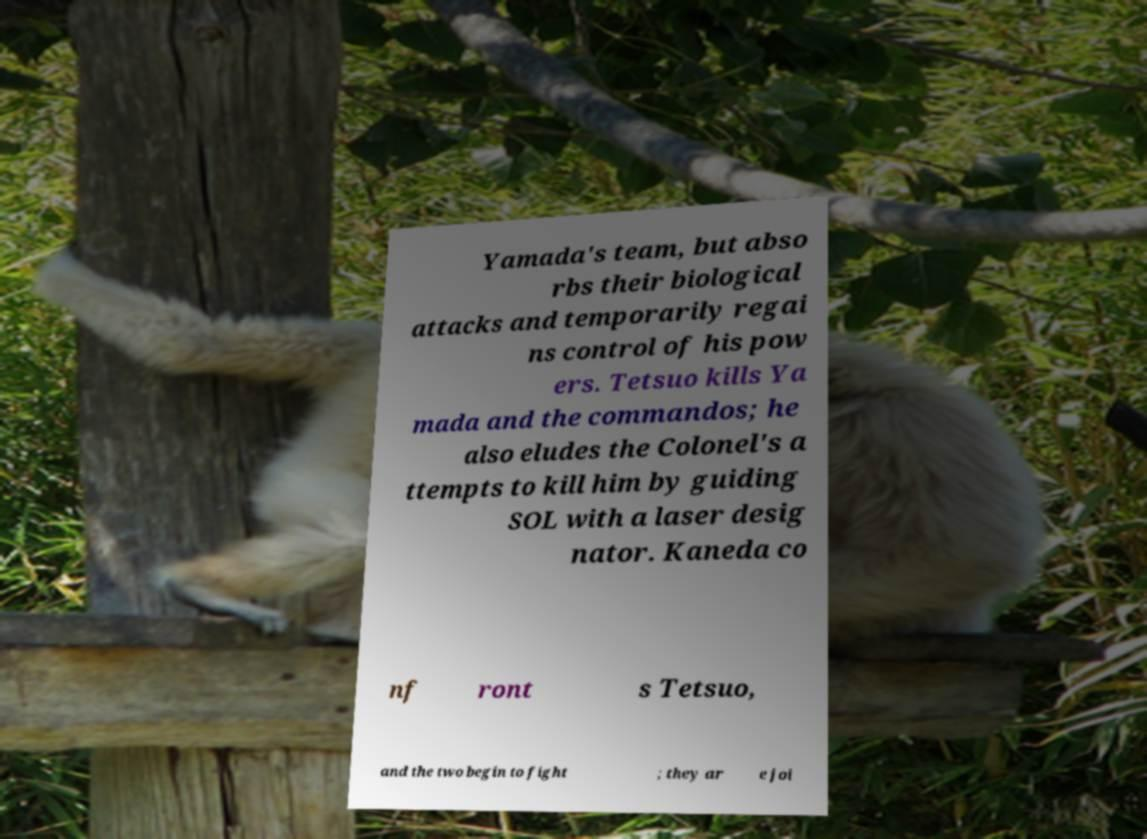Can you accurately transcribe the text from the provided image for me? Yamada's team, but abso rbs their biological attacks and temporarily regai ns control of his pow ers. Tetsuo kills Ya mada and the commandos; he also eludes the Colonel's a ttempts to kill him by guiding SOL with a laser desig nator. Kaneda co nf ront s Tetsuo, and the two begin to fight ; they ar e joi 